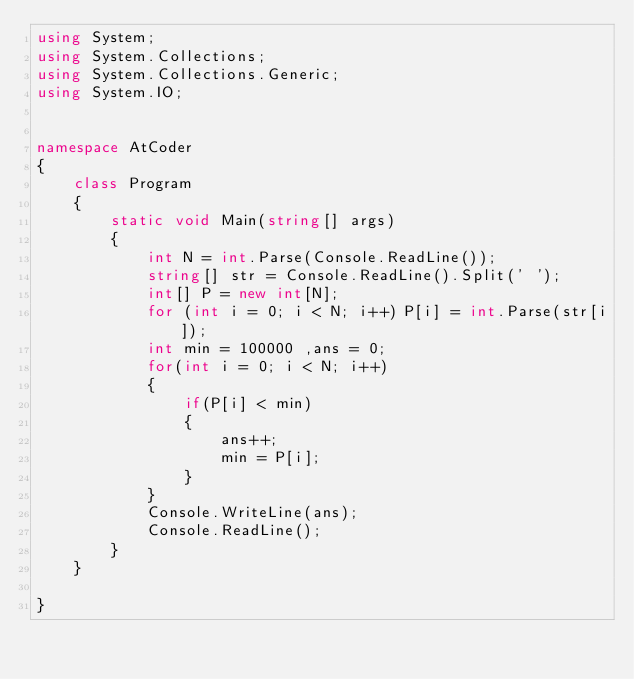<code> <loc_0><loc_0><loc_500><loc_500><_C#_>using System;
using System.Collections;
using System.Collections.Generic;
using System.IO;


namespace AtCoder
{
	class Program
	{
        static void Main(string[] args)
        {
            int N = int.Parse(Console.ReadLine());
            string[] str = Console.ReadLine().Split(' ');
            int[] P = new int[N];
            for (int i = 0; i < N; i++) P[i] = int.Parse(str[i]);
            int min = 100000 ,ans = 0;
            for(int i = 0; i < N; i++)
            {
                if(P[i] < min)
                {
                    ans++;
                    min = P[i];
                }
            }
            Console.WriteLine(ans);
            Console.ReadLine();
        }
    }
    
}
</code> 